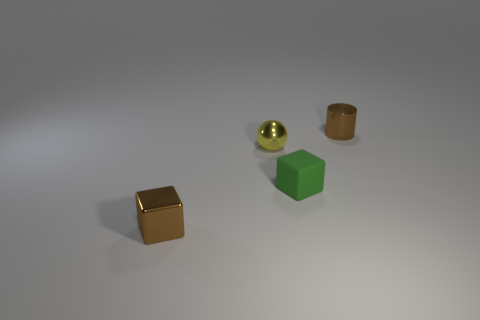Do the small metallic object that is right of the small sphere and the metal cube have the same color?
Provide a succinct answer. Yes. How many green things are matte cubes or small balls?
Offer a terse response. 1. How many other things are the same shape as the yellow metal thing?
Ensure brevity in your answer.  0. Does the tiny green cube have the same material as the small yellow object?
Keep it short and to the point. No. There is a small thing that is in front of the shiny sphere and to the right of the brown block; what material is it?
Give a very brief answer. Rubber. What is the color of the metal cylinder right of the tiny yellow sphere?
Your answer should be very brief. Brown. Is the number of matte objects behind the brown metal cylinder greater than the number of tiny matte cubes?
Make the answer very short. No. How many other things are there of the same size as the metal cube?
Your answer should be compact. 3. What number of objects are left of the small green block?
Provide a succinct answer. 2. Are there the same number of tiny brown shiny things that are on the left side of the yellow object and tiny rubber things to the right of the small rubber thing?
Keep it short and to the point. No. 